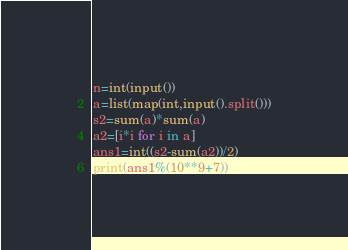<code> <loc_0><loc_0><loc_500><loc_500><_Python_>n=int(input())
a=list(map(int,input().split()))
s2=sum(a)*sum(a)
a2=[i*i for i in a]
ans1=int((s2-sum(a2))/2)
print(ans1%(10**9+7))</code> 